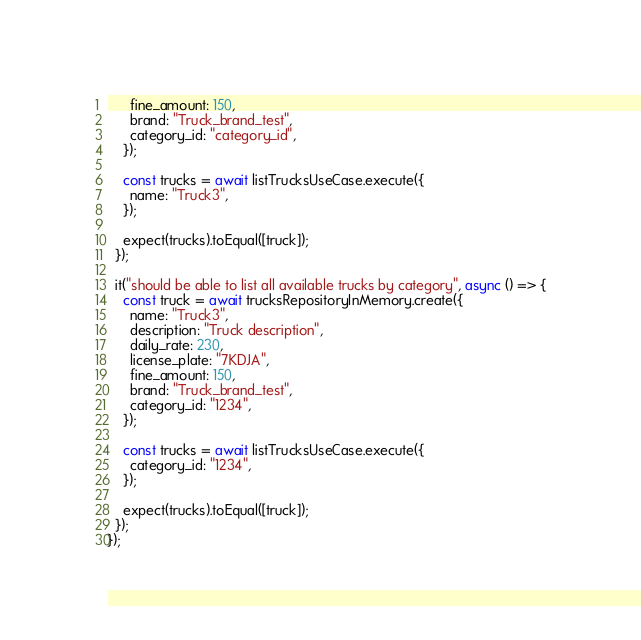Convert code to text. <code><loc_0><loc_0><loc_500><loc_500><_TypeScript_>      fine_amount: 150,
      brand: "Truck_brand_test",
      category_id: "category_id",
    });

    const trucks = await listTrucksUseCase.execute({
      name: "Truck3",
    });

    expect(trucks).toEqual([truck]);
  });

  it("should be able to list all available trucks by category", async () => {
    const truck = await trucksRepositoryInMemory.create({
      name: "Truck3",
      description: "Truck description",
      daily_rate: 230,
      license_plate: "7KDJA",
      fine_amount: 150,
      brand: "Truck_brand_test",
      category_id: "1234",
    });

    const trucks = await listTrucksUseCase.execute({
      category_id: "1234",
    });

    expect(trucks).toEqual([truck]);
  });
});
</code> 